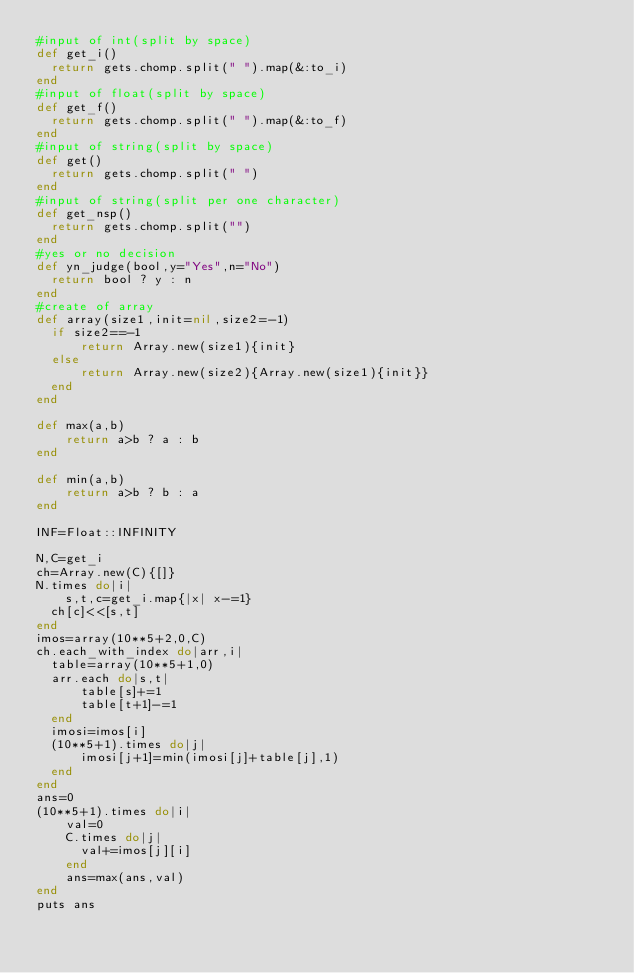<code> <loc_0><loc_0><loc_500><loc_500><_Ruby_>#input of int(split by space)
def get_i()
  return gets.chomp.split(" ").map(&:to_i)
end
#input of float(split by space)
def get_f()
  return gets.chomp.split(" ").map(&:to_f)
end
#input of string(split by space)
def get()
  return gets.chomp.split(" ")
end
#input of string(split per one character)
def get_nsp()
  return gets.chomp.split("")
end
#yes or no decision
def yn_judge(bool,y="Yes",n="No")
  return bool ? y : n 
end
#create of array
def array(size1,init=nil,size2=-1)
  if size2==-1
      return Array.new(size1){init}
  else
      return Array.new(size2){Array.new(size1){init}}
  end
end

def max(a,b)
    return a>b ? a : b
end

def min(a,b)
    return a>b ? b : a
end

INF=Float::INFINITY

N,C=get_i
ch=Array.new(C){[]}
N.times do|i|
    s,t,c=get_i.map{|x| x-=1}
  ch[c]<<[s,t]
end
imos=array(10**5+2,0,C)
ch.each_with_index do|arr,i|
  table=array(10**5+1,0)
  arr.each do|s,t|
      table[s]+=1
      table[t+1]-=1
  end  
  imosi=imos[i]
  (10**5+1).times do|j|
      imosi[j+1]=min(imosi[j]+table[j],1)
  end
end
ans=0
(10**5+1).times do|i|
    val=0
    C.times do|j|
      val+=imos[j][i]
    end
    ans=max(ans,val)
end
puts ans</code> 